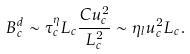Convert formula to latex. <formula><loc_0><loc_0><loc_500><loc_500>B _ { c } ^ { d } \sim \tau _ { c } ^ { \eta } L _ { c } \frac { C u _ { c } ^ { 2 } } { L _ { c } ^ { 2 } } \sim \eta _ { l } u _ { c } ^ { 2 } L _ { c } .</formula> 